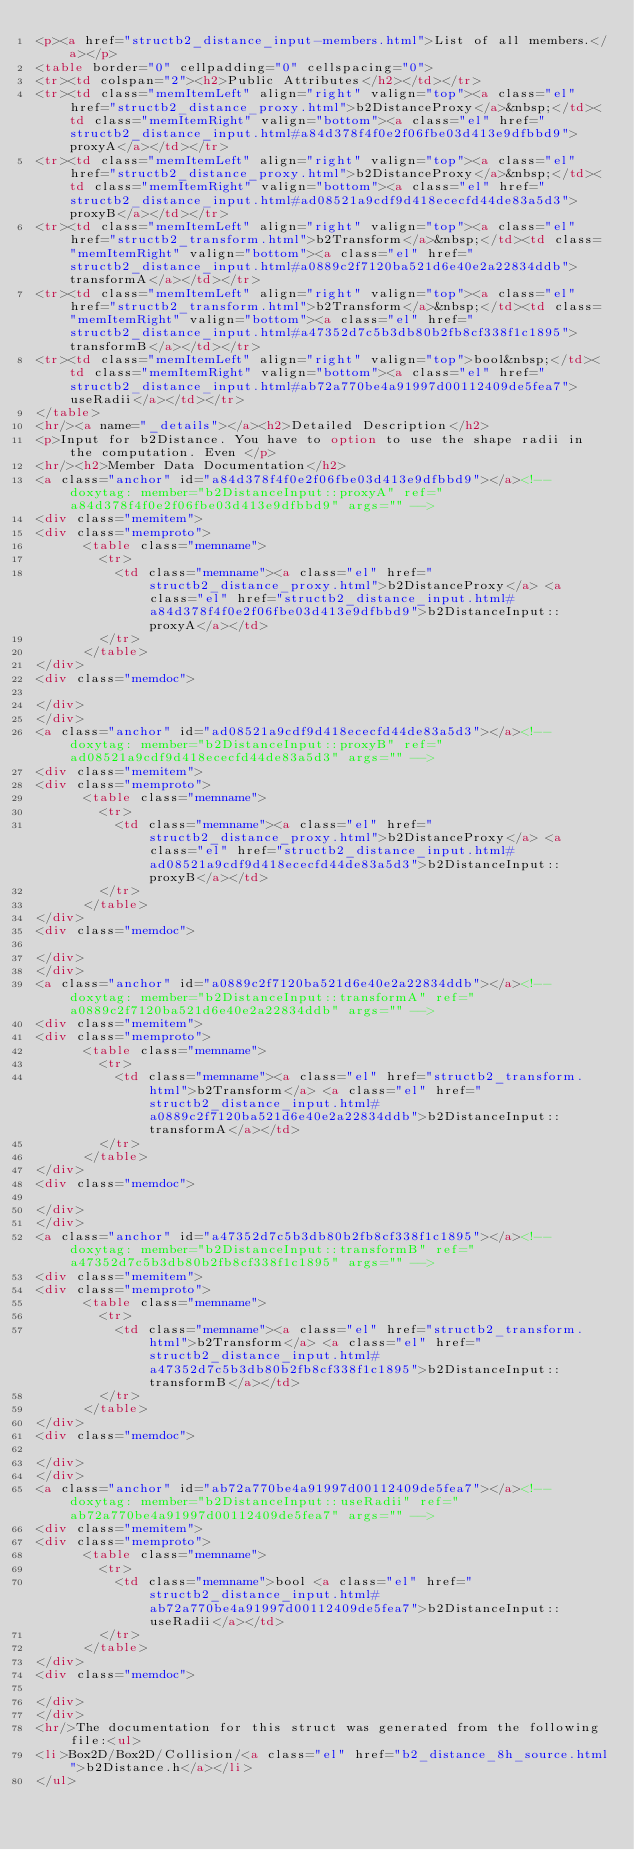<code> <loc_0><loc_0><loc_500><loc_500><_HTML_><p><a href="structb2_distance_input-members.html">List of all members.</a></p>
<table border="0" cellpadding="0" cellspacing="0">
<tr><td colspan="2"><h2>Public Attributes</h2></td></tr>
<tr><td class="memItemLeft" align="right" valign="top"><a class="el" href="structb2_distance_proxy.html">b2DistanceProxy</a>&nbsp;</td><td class="memItemRight" valign="bottom"><a class="el" href="structb2_distance_input.html#a84d378f4f0e2f06fbe03d413e9dfbbd9">proxyA</a></td></tr>
<tr><td class="memItemLeft" align="right" valign="top"><a class="el" href="structb2_distance_proxy.html">b2DistanceProxy</a>&nbsp;</td><td class="memItemRight" valign="bottom"><a class="el" href="structb2_distance_input.html#ad08521a9cdf9d418ececfd44de83a5d3">proxyB</a></td></tr>
<tr><td class="memItemLeft" align="right" valign="top"><a class="el" href="structb2_transform.html">b2Transform</a>&nbsp;</td><td class="memItemRight" valign="bottom"><a class="el" href="structb2_distance_input.html#a0889c2f7120ba521d6e40e2a22834ddb">transformA</a></td></tr>
<tr><td class="memItemLeft" align="right" valign="top"><a class="el" href="structb2_transform.html">b2Transform</a>&nbsp;</td><td class="memItemRight" valign="bottom"><a class="el" href="structb2_distance_input.html#a47352d7c5b3db80b2fb8cf338f1c1895">transformB</a></td></tr>
<tr><td class="memItemLeft" align="right" valign="top">bool&nbsp;</td><td class="memItemRight" valign="bottom"><a class="el" href="structb2_distance_input.html#ab72a770be4a91997d00112409de5fea7">useRadii</a></td></tr>
</table>
<hr/><a name="_details"></a><h2>Detailed Description</h2>
<p>Input for b2Distance. You have to option to use the shape radii in the computation. Even </p>
<hr/><h2>Member Data Documentation</h2>
<a class="anchor" id="a84d378f4f0e2f06fbe03d413e9dfbbd9"></a><!-- doxytag: member="b2DistanceInput::proxyA" ref="a84d378f4f0e2f06fbe03d413e9dfbbd9" args="" -->
<div class="memitem">
<div class="memproto">
      <table class="memname">
        <tr>
          <td class="memname"><a class="el" href="structb2_distance_proxy.html">b2DistanceProxy</a> <a class="el" href="structb2_distance_input.html#a84d378f4f0e2f06fbe03d413e9dfbbd9">b2DistanceInput::proxyA</a></td>
        </tr>
      </table>
</div>
<div class="memdoc">

</div>
</div>
<a class="anchor" id="ad08521a9cdf9d418ececfd44de83a5d3"></a><!-- doxytag: member="b2DistanceInput::proxyB" ref="ad08521a9cdf9d418ececfd44de83a5d3" args="" -->
<div class="memitem">
<div class="memproto">
      <table class="memname">
        <tr>
          <td class="memname"><a class="el" href="structb2_distance_proxy.html">b2DistanceProxy</a> <a class="el" href="structb2_distance_input.html#ad08521a9cdf9d418ececfd44de83a5d3">b2DistanceInput::proxyB</a></td>
        </tr>
      </table>
</div>
<div class="memdoc">

</div>
</div>
<a class="anchor" id="a0889c2f7120ba521d6e40e2a22834ddb"></a><!-- doxytag: member="b2DistanceInput::transformA" ref="a0889c2f7120ba521d6e40e2a22834ddb" args="" -->
<div class="memitem">
<div class="memproto">
      <table class="memname">
        <tr>
          <td class="memname"><a class="el" href="structb2_transform.html">b2Transform</a> <a class="el" href="structb2_distance_input.html#a0889c2f7120ba521d6e40e2a22834ddb">b2DistanceInput::transformA</a></td>
        </tr>
      </table>
</div>
<div class="memdoc">

</div>
</div>
<a class="anchor" id="a47352d7c5b3db80b2fb8cf338f1c1895"></a><!-- doxytag: member="b2DistanceInput::transformB" ref="a47352d7c5b3db80b2fb8cf338f1c1895" args="" -->
<div class="memitem">
<div class="memproto">
      <table class="memname">
        <tr>
          <td class="memname"><a class="el" href="structb2_transform.html">b2Transform</a> <a class="el" href="structb2_distance_input.html#a47352d7c5b3db80b2fb8cf338f1c1895">b2DistanceInput::transformB</a></td>
        </tr>
      </table>
</div>
<div class="memdoc">

</div>
</div>
<a class="anchor" id="ab72a770be4a91997d00112409de5fea7"></a><!-- doxytag: member="b2DistanceInput::useRadii" ref="ab72a770be4a91997d00112409de5fea7" args="" -->
<div class="memitem">
<div class="memproto">
      <table class="memname">
        <tr>
          <td class="memname">bool <a class="el" href="structb2_distance_input.html#ab72a770be4a91997d00112409de5fea7">b2DistanceInput::useRadii</a></td>
        </tr>
      </table>
</div>
<div class="memdoc">

</div>
</div>
<hr/>The documentation for this struct was generated from the following file:<ul>
<li>Box2D/Box2D/Collision/<a class="el" href="b2_distance_8h_source.html">b2Distance.h</a></li>
</ul></code> 